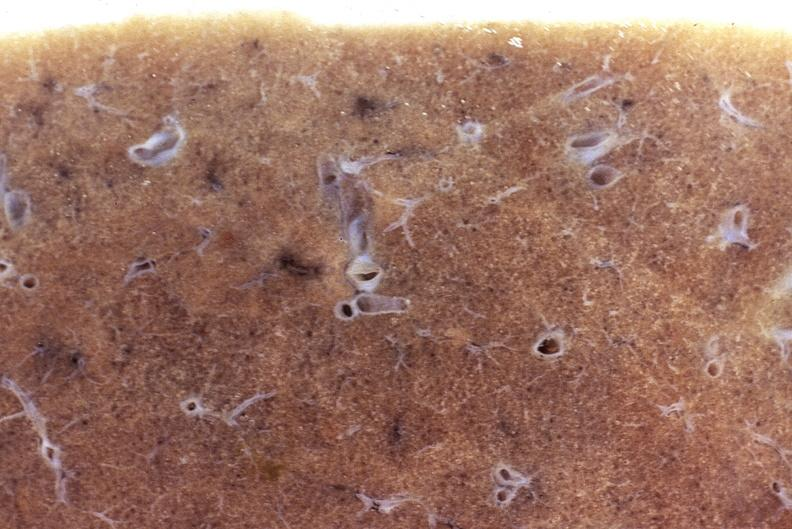what does this image show?
Answer the question using a single word or phrase. Normal lung 